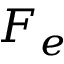<formula> <loc_0><loc_0><loc_500><loc_500>F _ { e }</formula> 